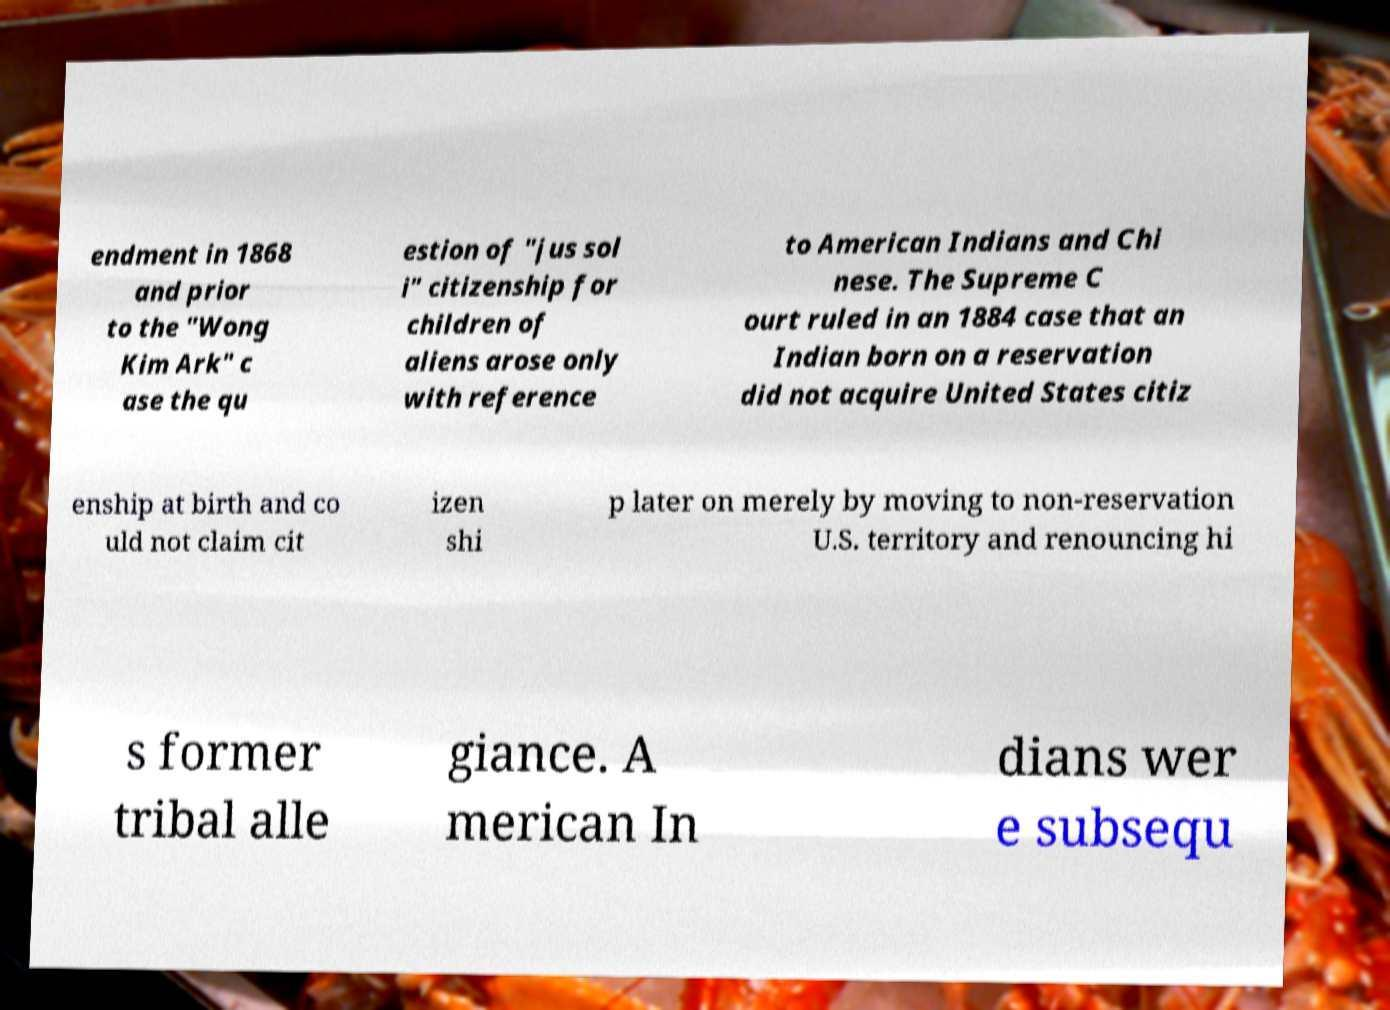I need the written content from this picture converted into text. Can you do that? endment in 1868 and prior to the "Wong Kim Ark" c ase the qu estion of "jus sol i" citizenship for children of aliens arose only with reference to American Indians and Chi nese. The Supreme C ourt ruled in an 1884 case that an Indian born on a reservation did not acquire United States citiz enship at birth and co uld not claim cit izen shi p later on merely by moving to non-reservation U.S. territory and renouncing hi s former tribal alle giance. A merican In dians wer e subsequ 